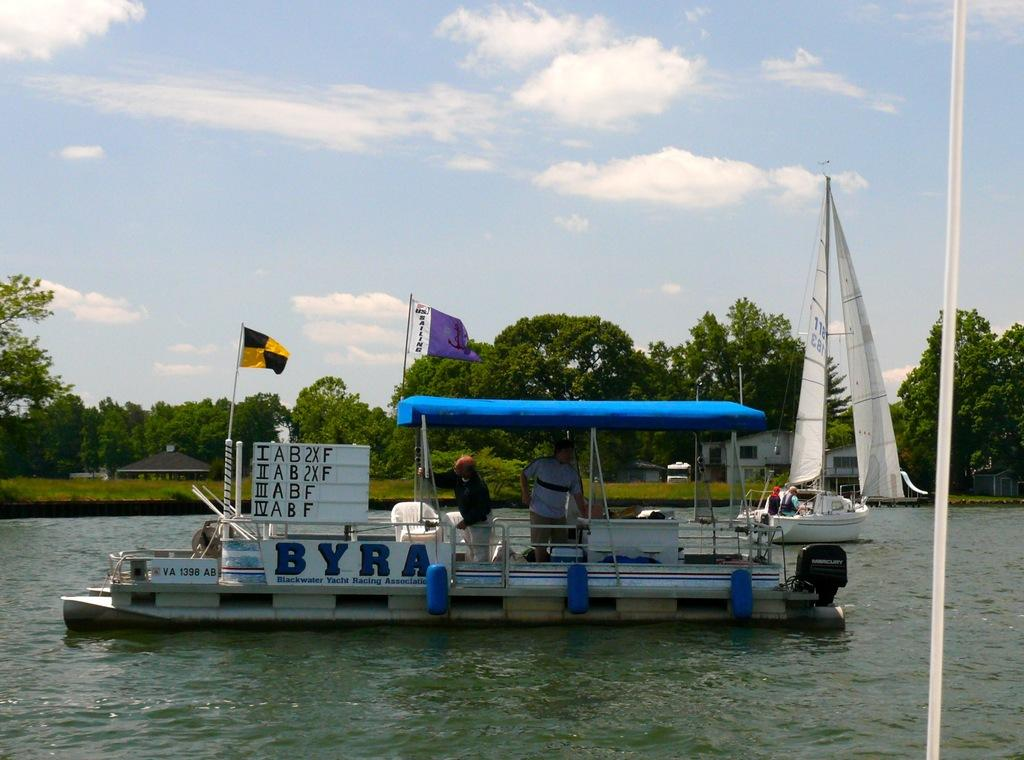Provide a one-sentence caption for the provided image. Out on a pond a small covered boat floating on the water with the word BYRA painted on the side of the boat. 